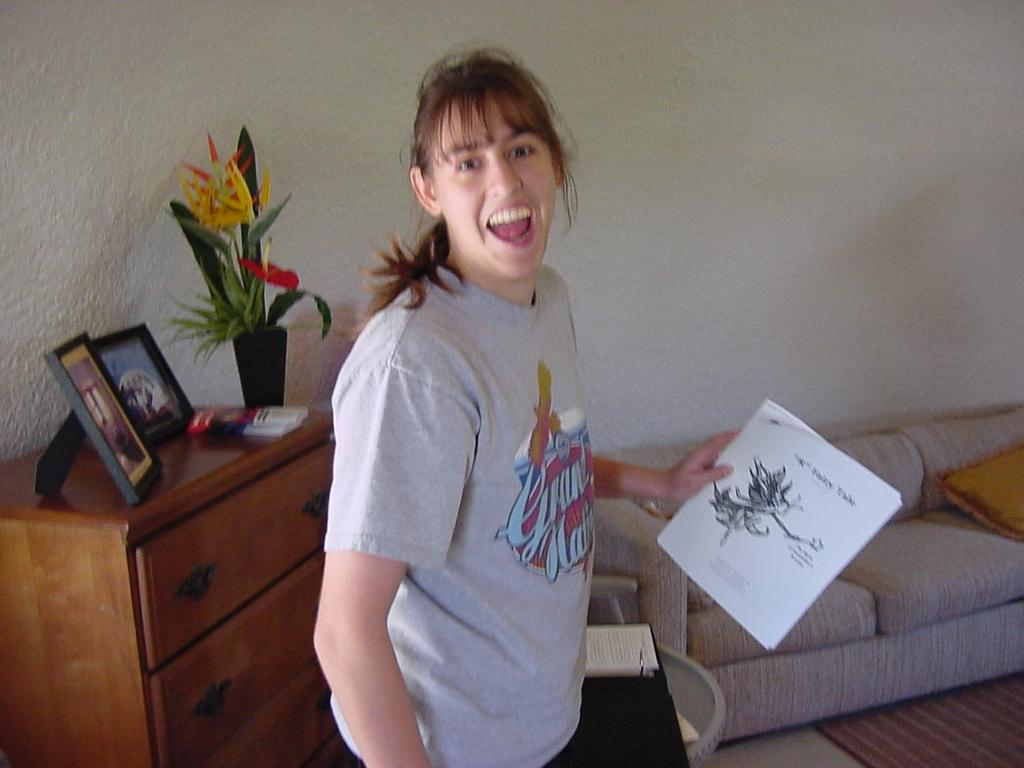What is the main subject of the image? There is a woman in the image. What is the woman doing in the image? The woman is standing and holding a book in her hand. How does the woman appear to be feeling in the image? The woman has a smile on her face, suggesting she is happy or content. What other objects can be seen in the image? There is a flower pot, two photo frames on a table, and a sofa in the image. What type of pen is the woman using to write in the image? There is no pen present in the image; the woman is holding a book, not writing. 